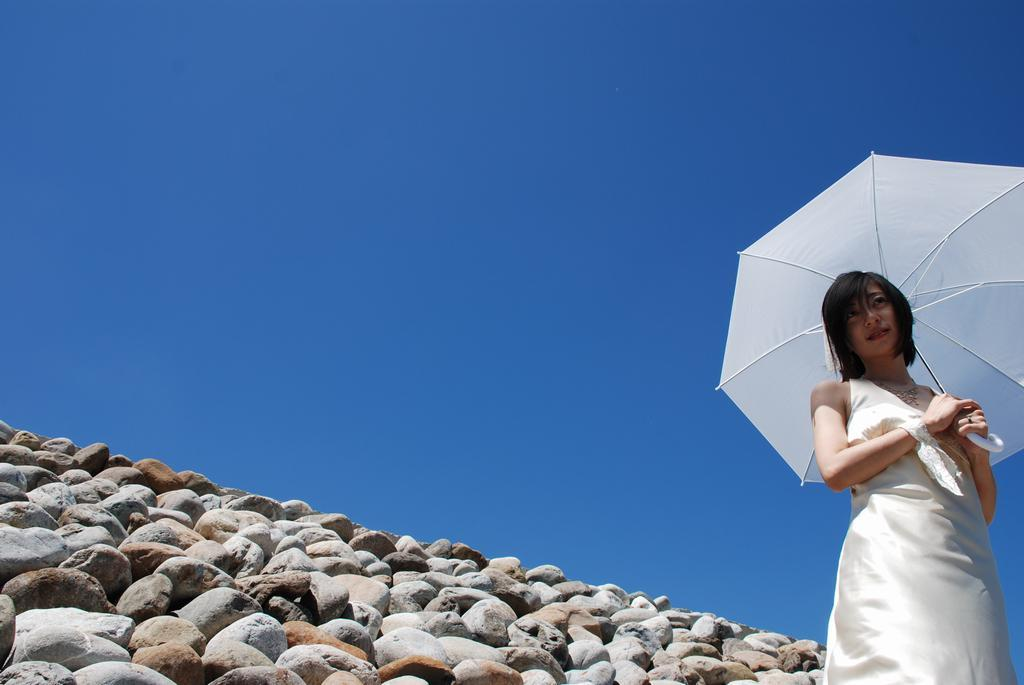Who is present in the image? There is a lady in the image. What is the lady holding in the image? The lady is holding an umbrella. What can be seen at the bottom of the image? There are stones at the bottom of the image. What is visible at the top of the image? The sky is visible at the top of the image. What type of sink can be seen in the image? There is no sink present in the image. What smell is associated with the lady in the image? There is no information about any smell in the image. 